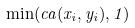<formula> <loc_0><loc_0><loc_500><loc_500>\min ( c a ( x _ { i } , y _ { i } ) , 1 )</formula> 